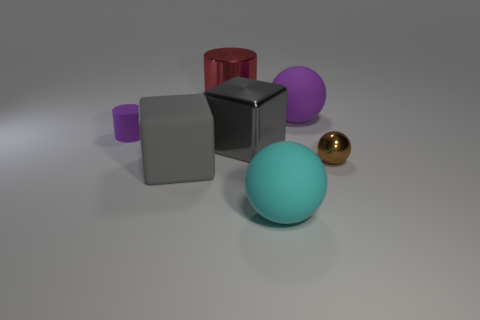Subtract all matte spheres. How many spheres are left? 1 Add 1 brown things. How many objects exist? 8 Subtract all purple cylinders. How many cylinders are left? 1 Subtract all blocks. How many objects are left? 5 Subtract all yellow cylinders. How many brown spheres are left? 1 Subtract 0 brown blocks. How many objects are left? 7 Subtract 2 cylinders. How many cylinders are left? 0 Subtract all yellow balls. Subtract all brown cylinders. How many balls are left? 3 Subtract all small objects. Subtract all large cyan objects. How many objects are left? 4 Add 1 large matte blocks. How many large matte blocks are left? 2 